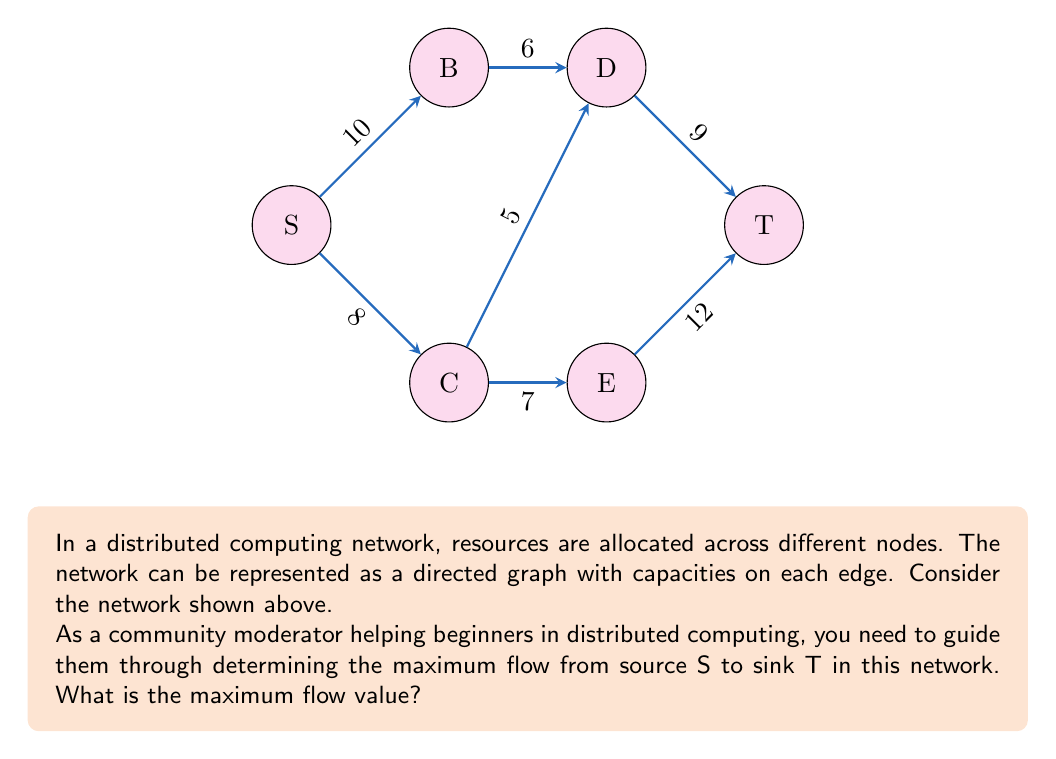Show me your answer to this math problem. To solve this problem, we'll use the Ford-Fulkerson algorithm, which is commonly used in distributed computing for resource allocation. Here's a step-by-step explanation:

1) Start with zero flow on all edges.

2) Find an augmenting path from S to T:
   Path 1: S -> B -> D -> T (min capacity = 6)
   Augment flow by 6. Remaining capacities:
   S -> B: 4, B -> D: 0, D -> T: 3

3) Find another augmenting path:
   Path 2: S -> C -> D -> T (min capacity = 3)
   Augment flow by 3. Remaining capacities:
   S -> C: 5, C -> D: 2, D -> T: 0

4) Find another augmenting path:
   Path 3: S -> C -> E -> T (min capacity = 5)
   Augment flow by 5. Remaining capacities:
   S -> C: 0, C -> E: 2, E -> T: 7

5) No more augmenting paths exist from S to T.

6) Calculate total flow:
   $$\text{Total Flow} = 6 + 3 + 5 = 14$$

The maximum flow is achieved when no more augmenting paths can be found. In this case, the maximum flow is 14 units.

This problem demonstrates how resource allocation in distributed systems can be modeled as a network flow problem, where the goal is to maximize the flow of resources from a source to a sink while respecting capacity constraints on the network links.
Answer: 14 units 